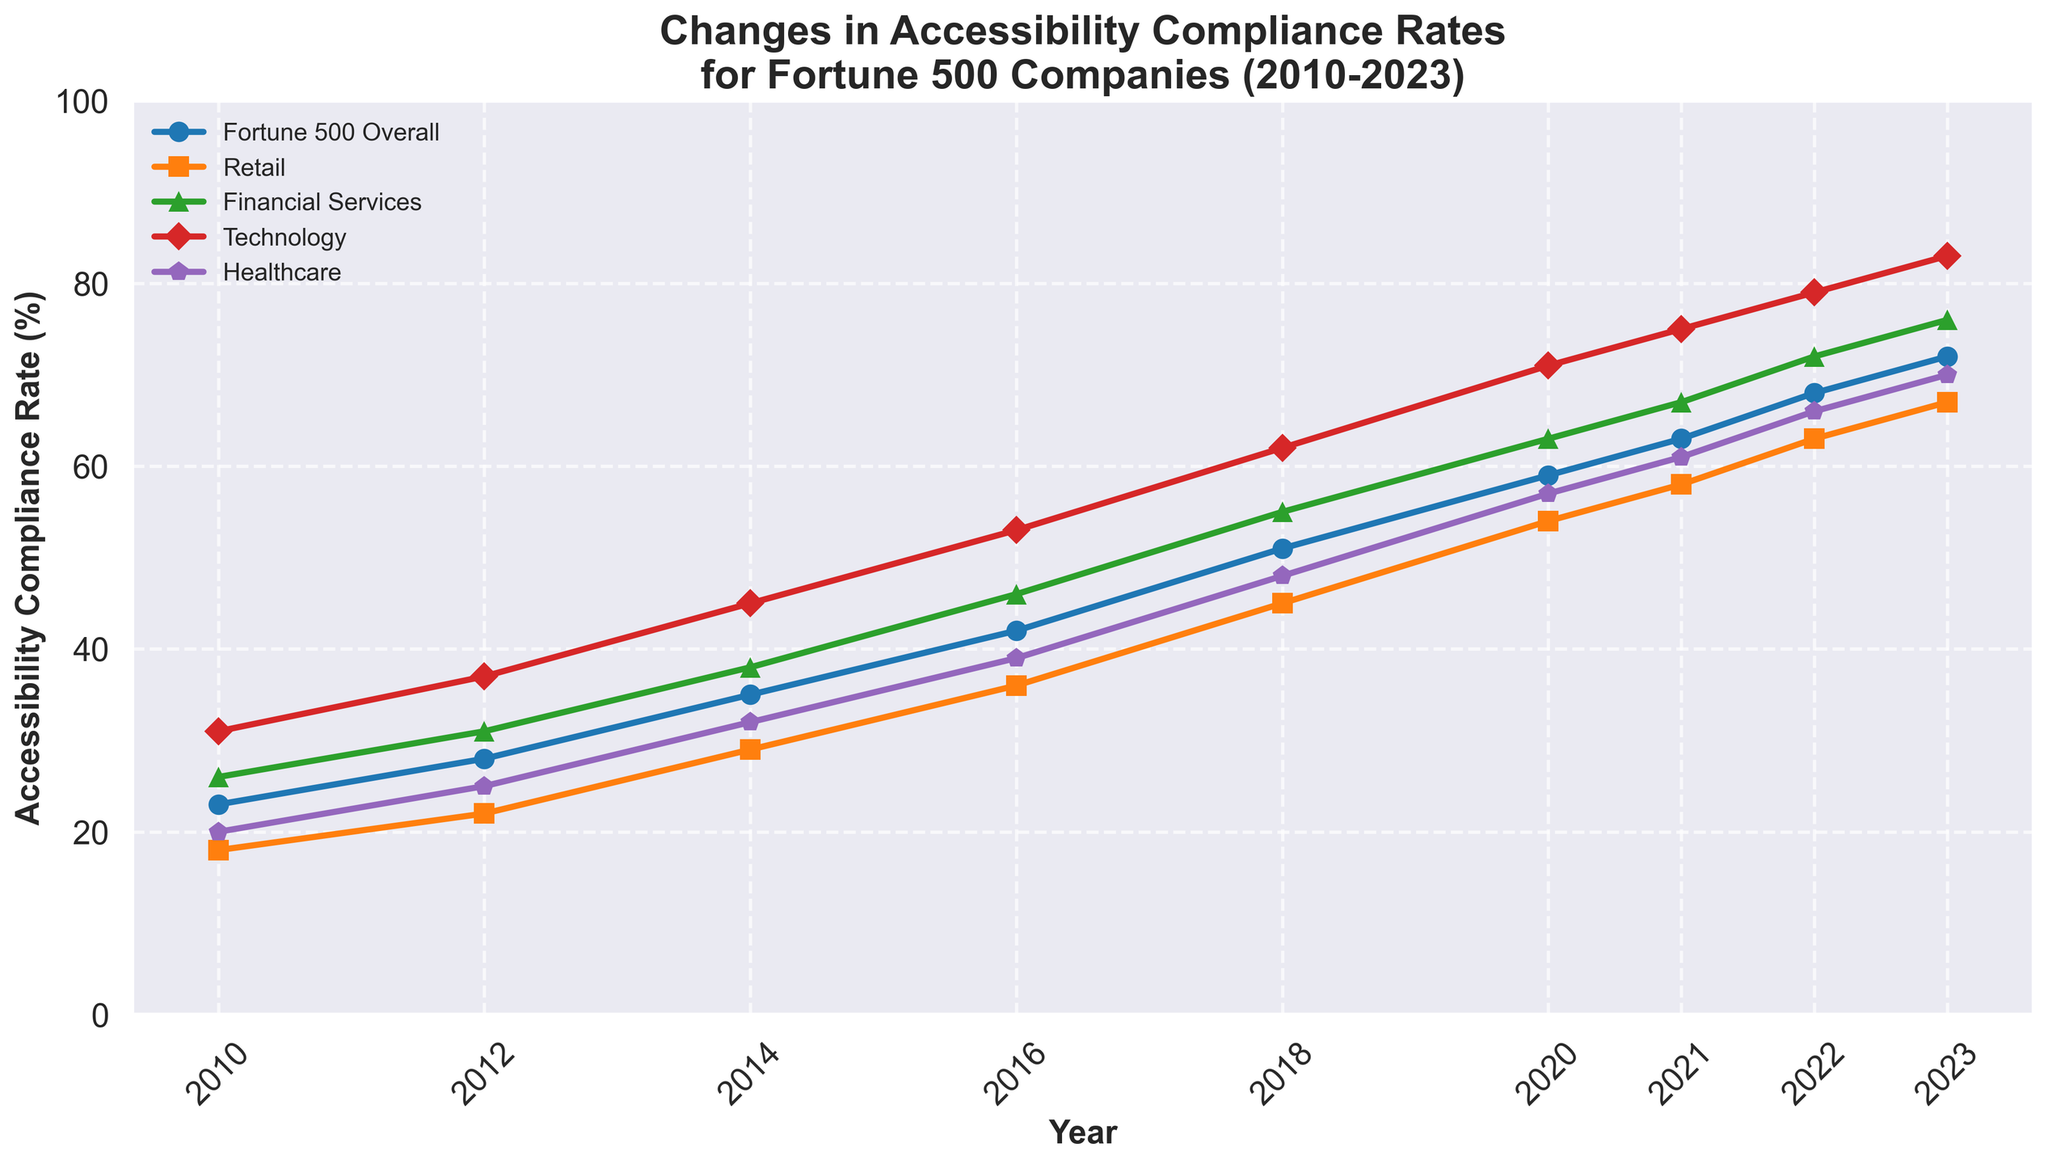What year did the Technology sector reach an accessibility compliance rate of over 80%? By examining the Technology sector's line in the plot and looking at the corresponding years, it is noticeable that the rate exceeds 80% in 2023.
Answer: 2023 Which sector had the highest accessibility compliance rate in 2020? Identify the highest line in the plot for the year 2020 and refer to the legend to find out which sector it represents. In 2020, the Technology sector had the highest compliance rate.
Answer: Technology Has the compliance rate for the Retail sector increased, decreased, or stayed the same between 2022 and 2023? Check the Retail sector's line for 2022 and 2023 and compare the values. The compliance rate increased from 63% in 2022 to 67% in 2023.
Answer: Increased What is the average compliance rate for the Healthcare sector from 2014 to 2018? Sum the compliance rates for Healthcare in 2014 (32%), 2016 (39%), and 2018 (48%), then divide by the number of periods (3). Calculation: (32% + 39% + 48%) / 3 = 39.67%.
Answer: 39.67% Which two sectors had the largest increase in compliance rates from 2010 to 2023? Subtract the 2010 compliance rates from the 2023 rates for each sector and compare the differences. The Technology sector increased from 31% to 83% (52% increase), and Financial Services increased from 26% to 76% (50% increase).
Answer: Technology and Financial Services Is the compliance rate for the Fortune 500 Overall higher or lower than the Healthcare sector in 2021? Compare the compliance rates for the Fortune 500 Overall (63%) and Healthcare (61%) in 2021. The Fortune 500 Overall has a higher rate.
Answer: Higher What is the difference in compliance rates between the Financial Services and Retail sectors in 2016? Subtract the Retail sector's compliance rate in 2016 (36%) from the Financial Services sector's rate in the same year (46%). Calculation: 46% - 36% = 10%.
Answer: 10% In which year did the overall accessibility compliance rate for Fortune 500 companies first exceed 50%? Identify the first year on the plot where the Fortune 500 Overall line crosses above the 50% mark. The rate first exceeds 50% in 2018.
Answer: 2018 